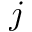Convert formula to latex. <formula><loc_0><loc_0><loc_500><loc_500>j</formula> 